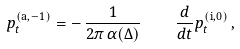<formula> <loc_0><loc_0><loc_500><loc_500>p _ { t } ^ { ( \text {a} , - 1 ) } = - \, \frac { 1 } { 2 \pi \, \alpha ( \Delta ) } \quad \frac { d } { d t } p _ { t } ^ { ( \text {i} , 0 ) } \, ,</formula> 